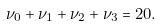<formula> <loc_0><loc_0><loc_500><loc_500>\nu _ { 0 } + \nu _ { 1 } + \nu _ { 2 } + \nu _ { 3 } = 2 0 .</formula> 